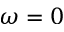Convert formula to latex. <formula><loc_0><loc_0><loc_500><loc_500>\omega = 0</formula> 